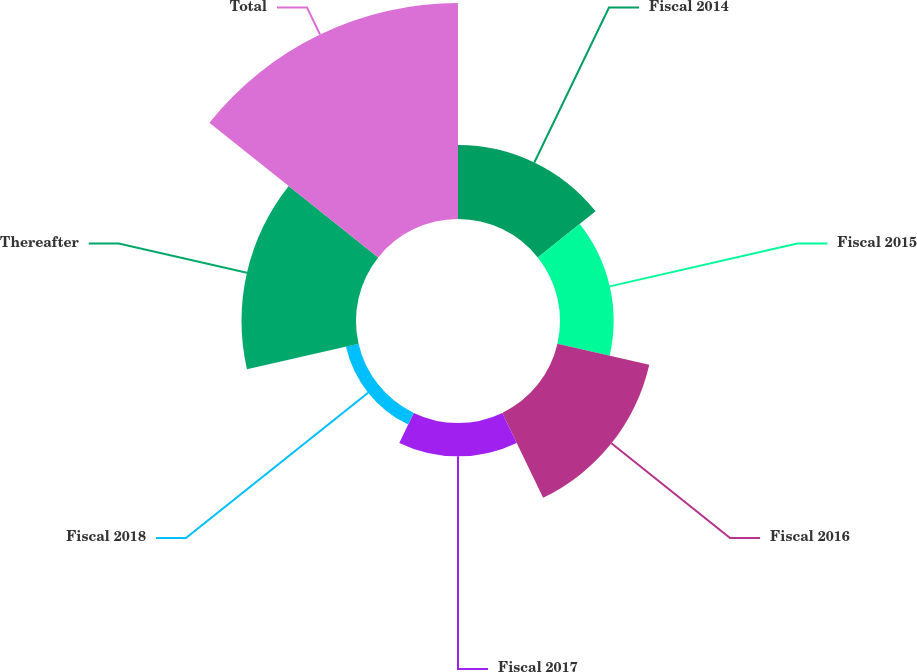Convert chart to OTSL. <chart><loc_0><loc_0><loc_500><loc_500><pie_chart><fcel>Fiscal 2014<fcel>Fiscal 2015<fcel>Fiscal 2016<fcel>Fiscal 2017<fcel>Fiscal 2018<fcel>Thereafter<fcel>Total<nl><fcel>12.35%<fcel>8.96%<fcel>15.74%<fcel>5.57%<fcel>2.17%<fcel>19.13%<fcel>36.09%<nl></chart> 